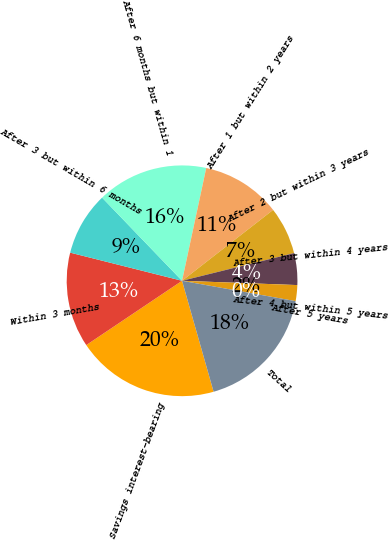Convert chart to OTSL. <chart><loc_0><loc_0><loc_500><loc_500><pie_chart><fcel>Savings interest-bearing<fcel>Within 3 months<fcel>After 3 but within 6 months<fcel>After 6 months but within 1<fcel>After 1 but within 2 years<fcel>After 2 but within 3 years<fcel>After 3 but within 4 years<fcel>After 4 but within 5 years<fcel>After 5 years<fcel>Total<nl><fcel>20.0%<fcel>13.33%<fcel>8.89%<fcel>15.55%<fcel>11.11%<fcel>6.67%<fcel>4.45%<fcel>2.23%<fcel>0.0%<fcel>17.77%<nl></chart> 